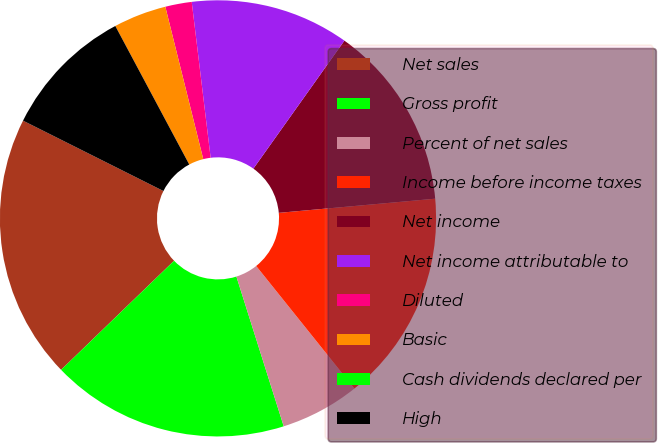<chart> <loc_0><loc_0><loc_500><loc_500><pie_chart><fcel>Net sales<fcel>Gross profit<fcel>Percent of net sales<fcel>Income before income taxes<fcel>Net income<fcel>Net income attributable to<fcel>Diluted<fcel>Basic<fcel>Cash dividends declared per<fcel>High<nl><fcel>19.61%<fcel>17.65%<fcel>5.88%<fcel>15.68%<fcel>13.72%<fcel>11.76%<fcel>1.96%<fcel>3.92%<fcel>0.0%<fcel>9.8%<nl></chart> 